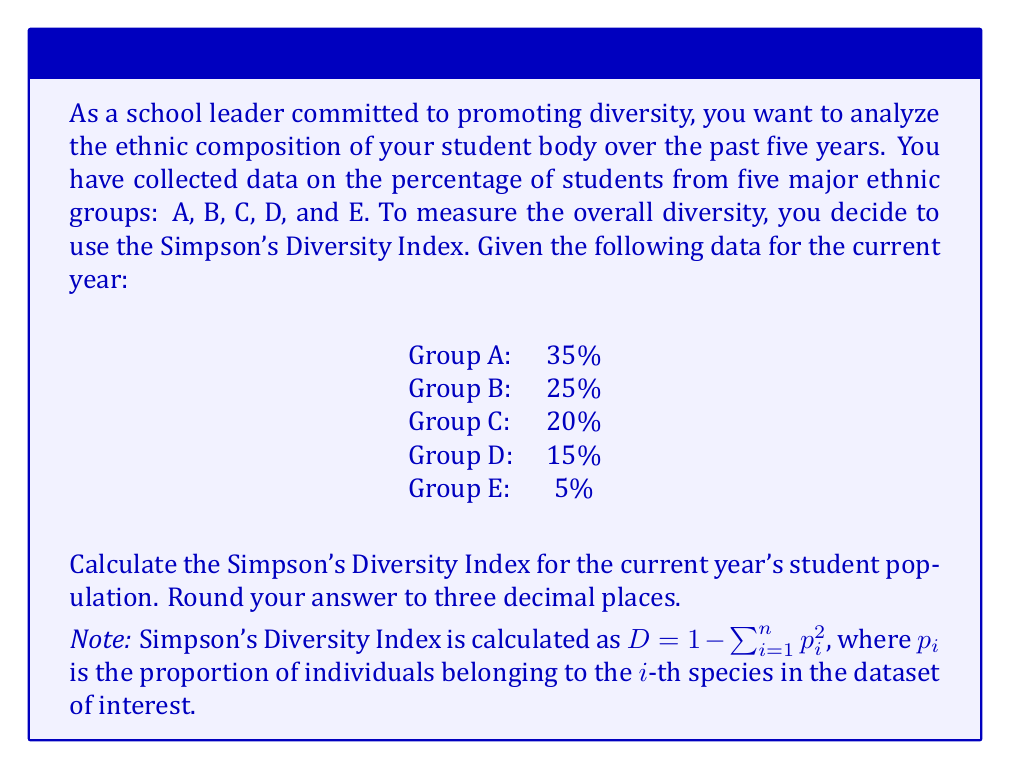Give your solution to this math problem. To calculate the Simpson's Diversity Index, we'll follow these steps:

1) First, we need to convert the percentages to proportions by dividing each by 100:

   A: 35% = 0.35
   B: 25% = 0.25
   C: 20% = 0.20
   D: 15% = 0.15
   E: 5%  = 0.05

2) Now, we square each of these proportions:

   $0.35^2 = 0.1225$
   $0.25^2 = 0.0625$
   $0.20^2 = 0.0400$
   $0.15^2 = 0.0225$
   $0.05^2 = 0.0025$

3) We sum these squared proportions:

   $\sum_{i=1}^n p_i^2 = 0.1225 + 0.0625 + 0.0400 + 0.0225 + 0.0025 = 0.2500$

4) Finally, we subtract this sum from 1 to get the Simpson's Diversity Index:

   $D = 1 - \sum_{i=1}^n p_i^2 = 1 - 0.2500 = 0.7500$

5) Rounding to three decimal places:

   $D \approx 0.750$

The Simpson's Diversity Index ranges from 0 to 1, where 0 represents no diversity (one group dominates completely) and 1 represents infinite diversity. A value of 0.750 indicates a relatively high level of diversity in the student population.
Answer: 0.750 